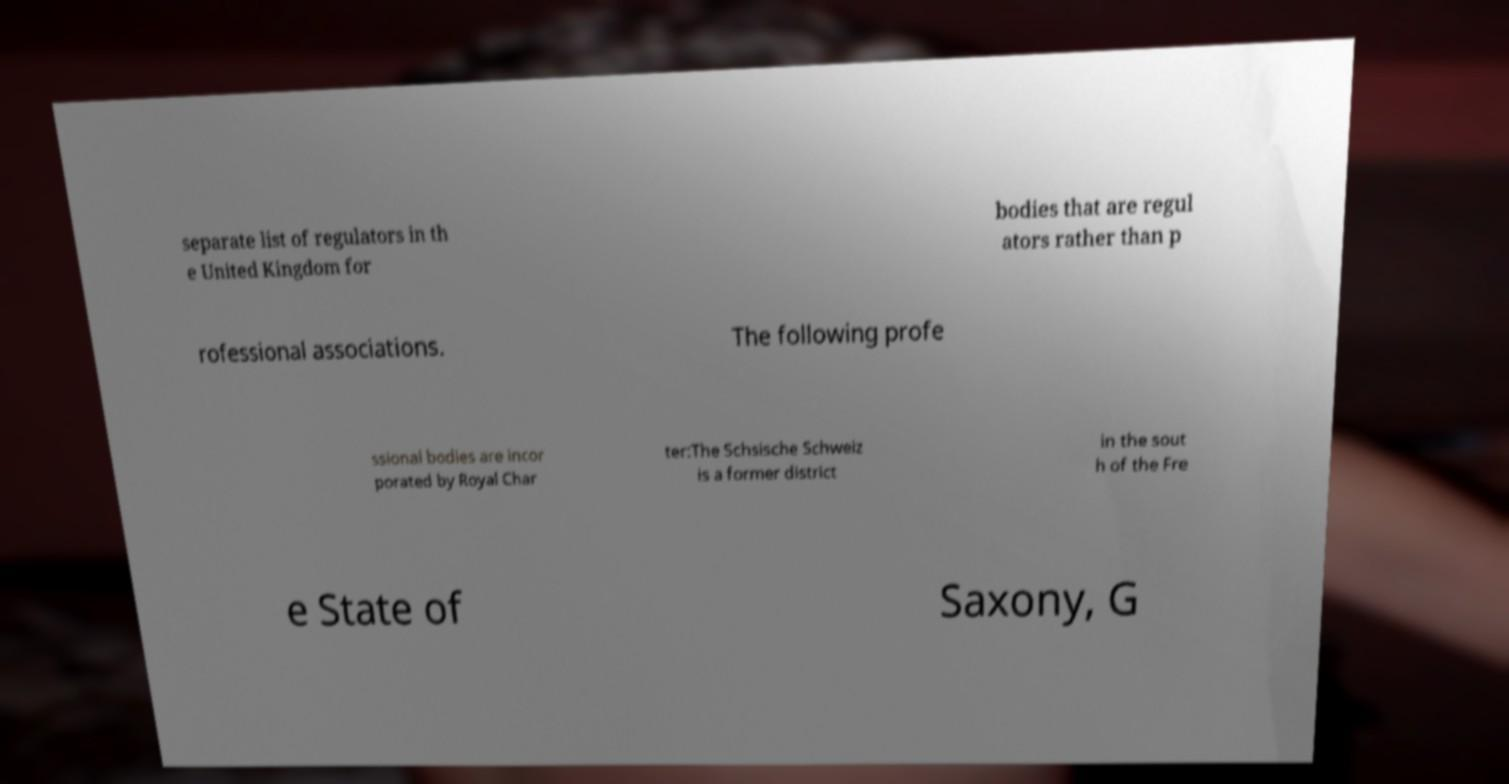Could you extract and type out the text from this image? separate list of regulators in th e United Kingdom for bodies that are regul ators rather than p rofessional associations. The following profe ssional bodies are incor porated by Royal Char ter:The Schsische Schweiz is a former district in the sout h of the Fre e State of Saxony, G 